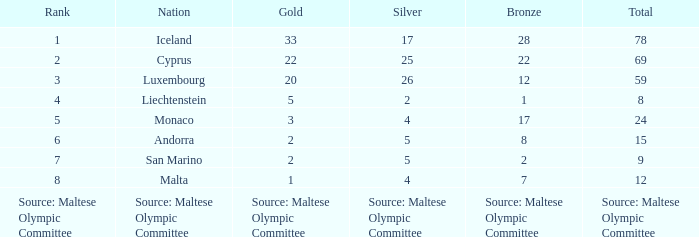What is the amount of gold medals when there are 8 bronze medals? 2.0. 